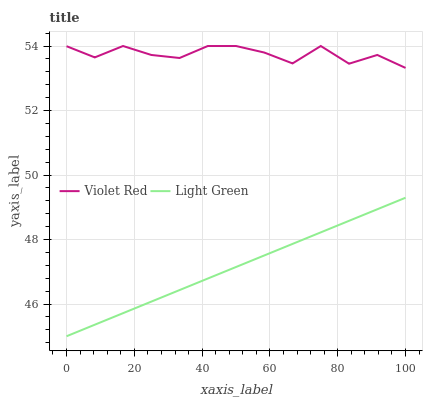Does Light Green have the minimum area under the curve?
Answer yes or no. Yes. Does Violet Red have the maximum area under the curve?
Answer yes or no. Yes. Does Light Green have the maximum area under the curve?
Answer yes or no. No. Is Light Green the smoothest?
Answer yes or no. Yes. Is Violet Red the roughest?
Answer yes or no. Yes. Is Light Green the roughest?
Answer yes or no. No. Does Light Green have the lowest value?
Answer yes or no. Yes. Does Violet Red have the highest value?
Answer yes or no. Yes. Does Light Green have the highest value?
Answer yes or no. No. Is Light Green less than Violet Red?
Answer yes or no. Yes. Is Violet Red greater than Light Green?
Answer yes or no. Yes. Does Light Green intersect Violet Red?
Answer yes or no. No. 